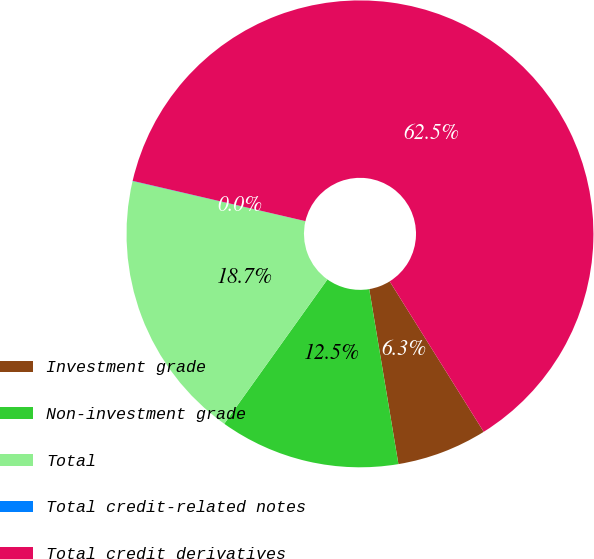<chart> <loc_0><loc_0><loc_500><loc_500><pie_chart><fcel>Investment grade<fcel>Non-investment grade<fcel>Total<fcel>Total credit-related notes<fcel>Total credit derivatives<nl><fcel>6.26%<fcel>12.51%<fcel>18.75%<fcel>0.02%<fcel>62.47%<nl></chart> 